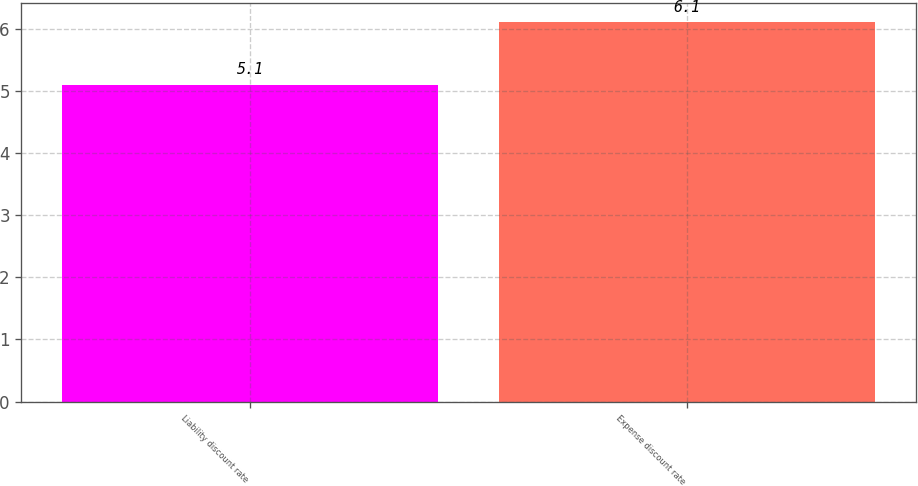<chart> <loc_0><loc_0><loc_500><loc_500><bar_chart><fcel>Liability discount rate<fcel>Expense discount rate<nl><fcel>5.1<fcel>6.1<nl></chart> 